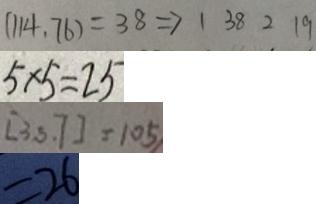<formula> <loc_0><loc_0><loc_500><loc_500>( 1 1 4 , 7 6 ) = 3 8 \Rightarrow 1 3 8 2 1 9 
 5 \times 5 = 2 5 
 [ 3 , 5 , 7 ] = 1 0 5 
 = 2 6</formula> 